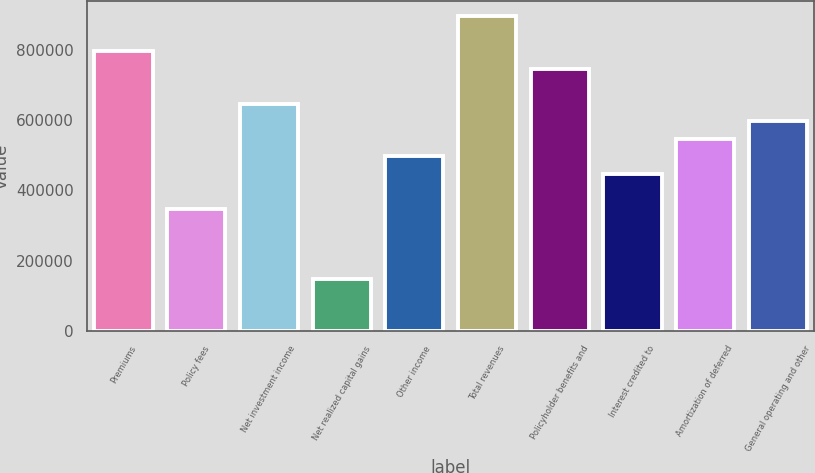Convert chart to OTSL. <chart><loc_0><loc_0><loc_500><loc_500><bar_chart><fcel>Premiums<fcel>Policy fees<fcel>Net investment income<fcel>Net realized capital gains<fcel>Other income<fcel>Total revenues<fcel>Policyholder benefits and<fcel>Interest credited to<fcel>Amortization of deferred<fcel>General operating and other<nl><fcel>795108<fcel>347861<fcel>646025<fcel>149084<fcel>496943<fcel>894496<fcel>745414<fcel>447249<fcel>546637<fcel>596331<nl></chart> 